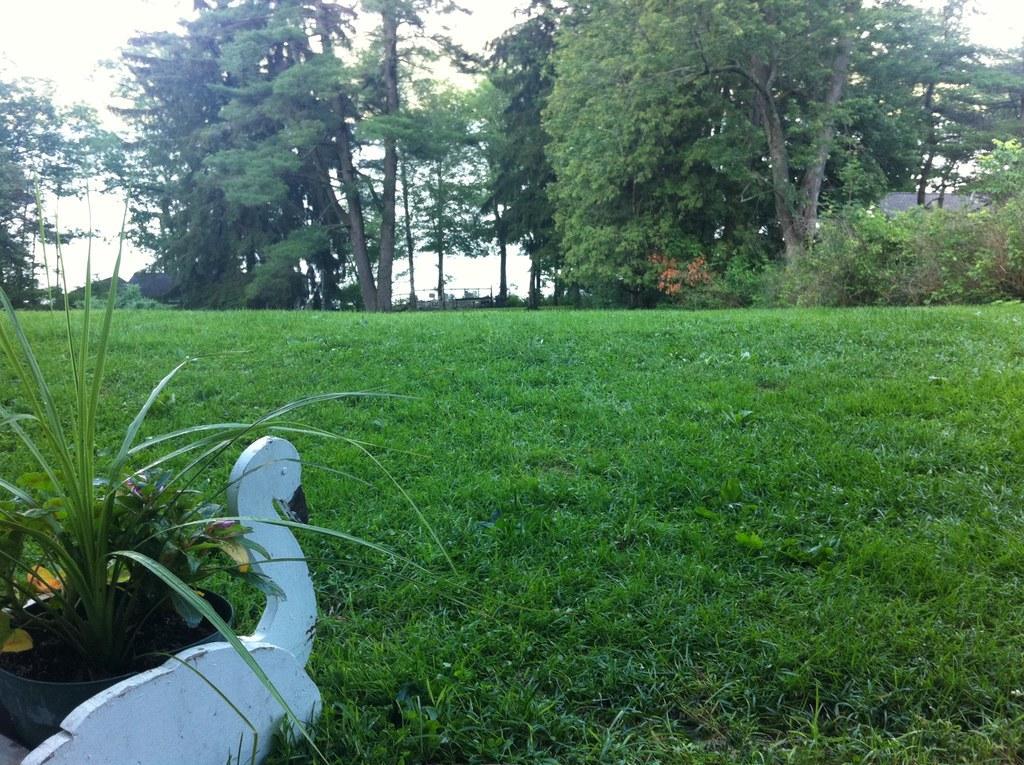In one or two sentences, can you explain what this image depicts? On the left we can see a house plant in a pot on a bird sculpture,In the background we can see grass on the ground,trees,houses,other objects and sky. 